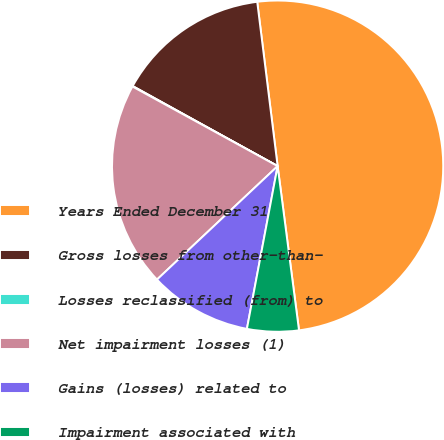Convert chart. <chart><loc_0><loc_0><loc_500><loc_500><pie_chart><fcel>Years Ended December 31<fcel>Gross losses from other-than-<fcel>Losses reclassified (from) to<fcel>Net impairment losses (1)<fcel>Gains (losses) related to<fcel>Impairment associated with<nl><fcel>49.9%<fcel>15.0%<fcel>0.05%<fcel>19.99%<fcel>10.02%<fcel>5.03%<nl></chart> 